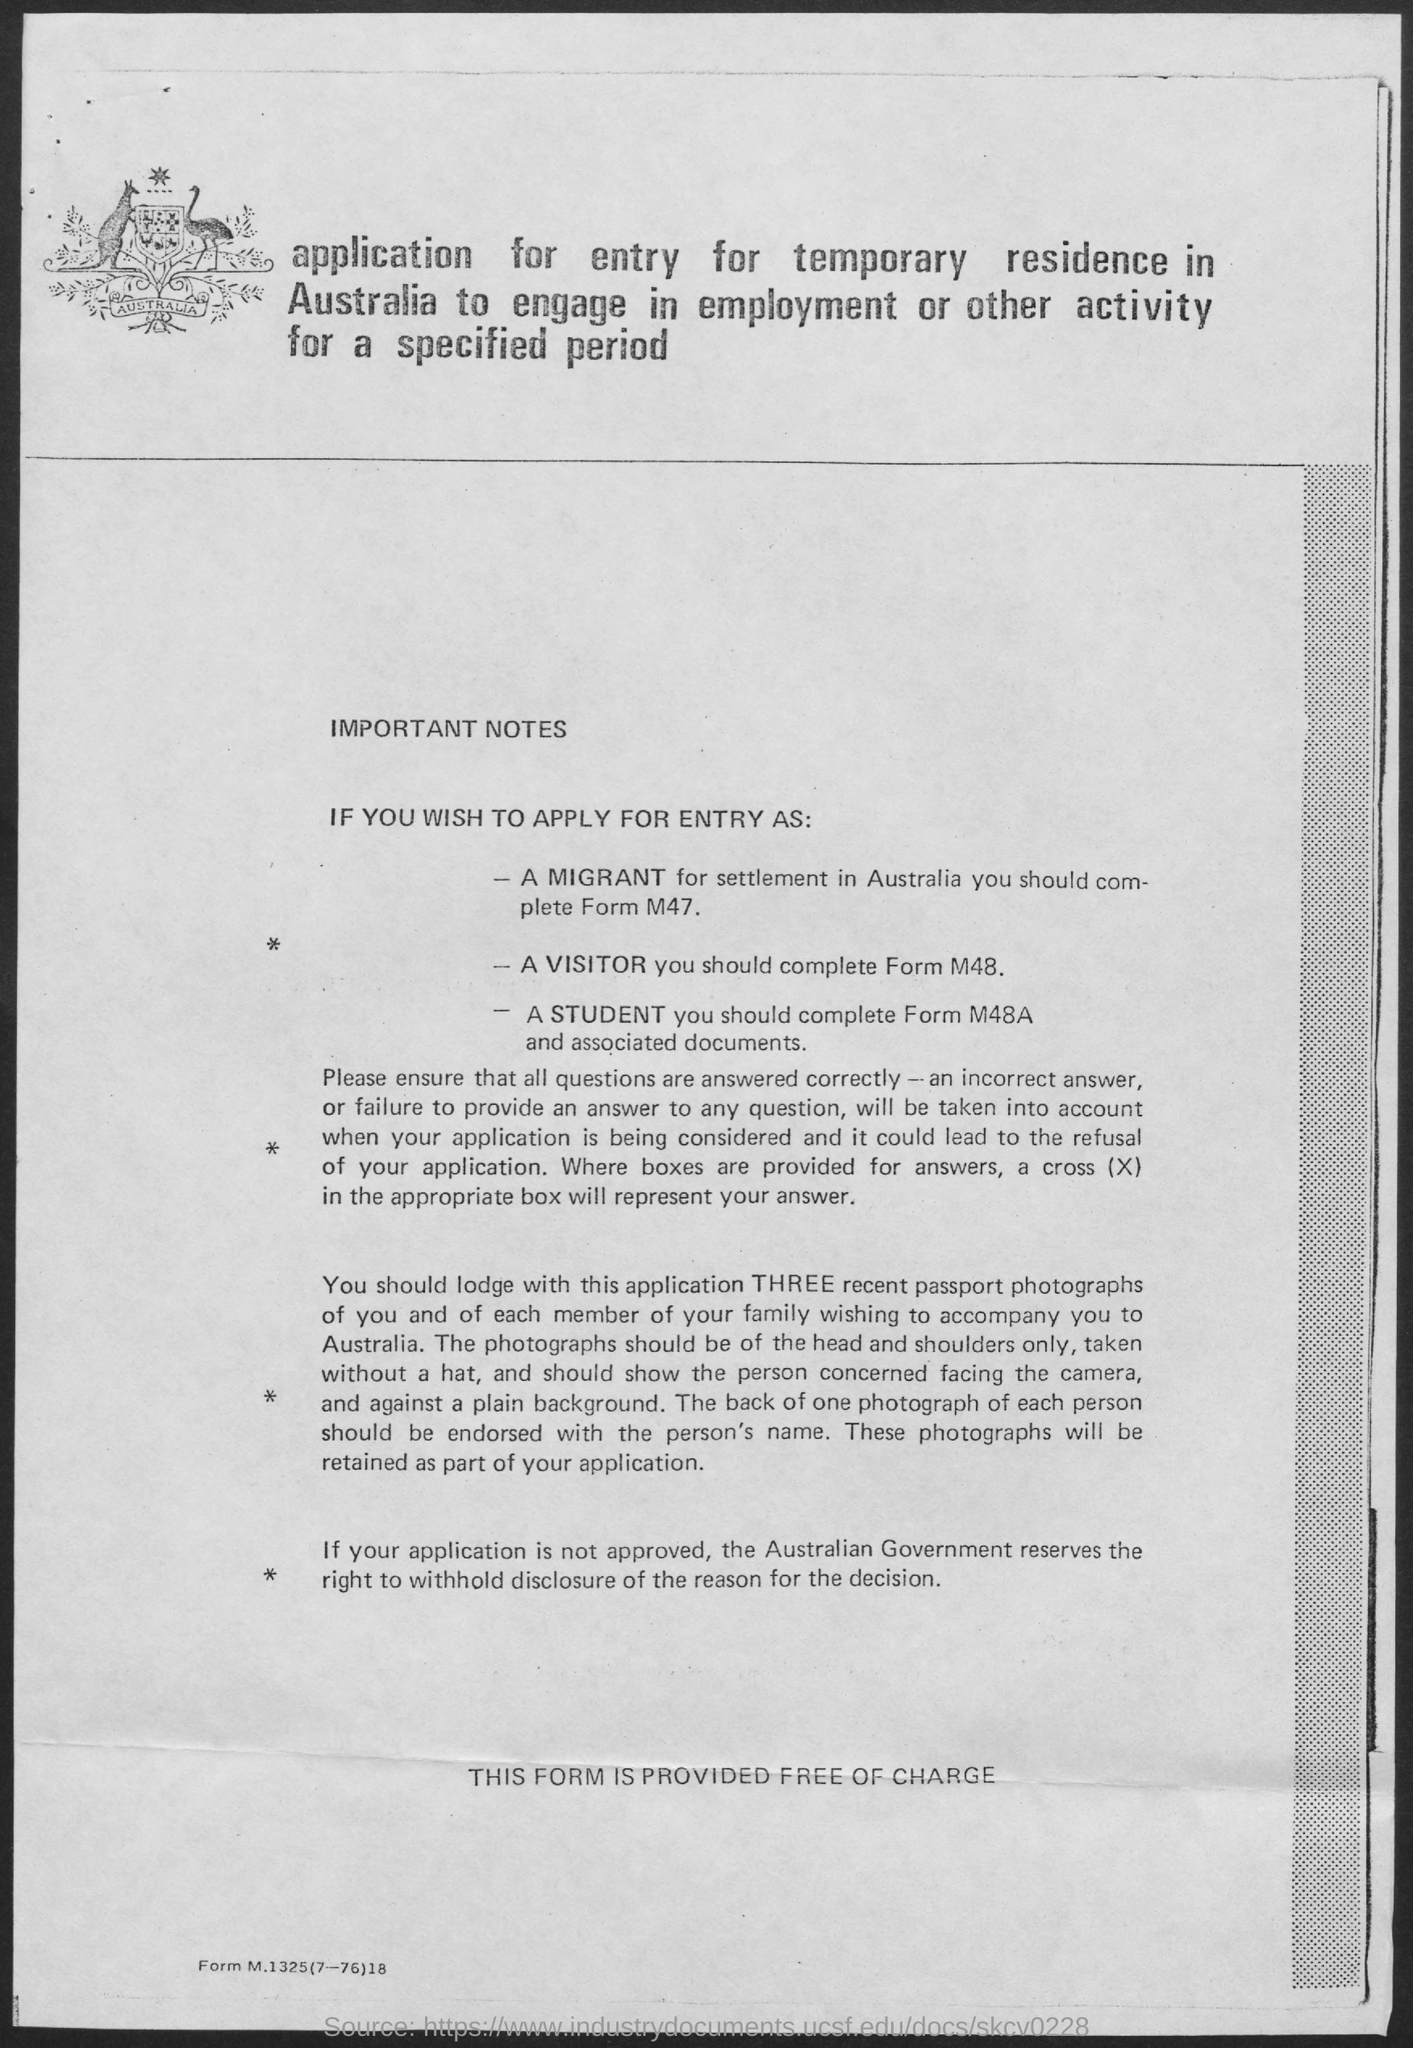Indicate a few pertinent items in this graphic. The cost of the form is free of charge. The form that a migrant should complete is M47. The form that should be completed by a visitor is M48. 